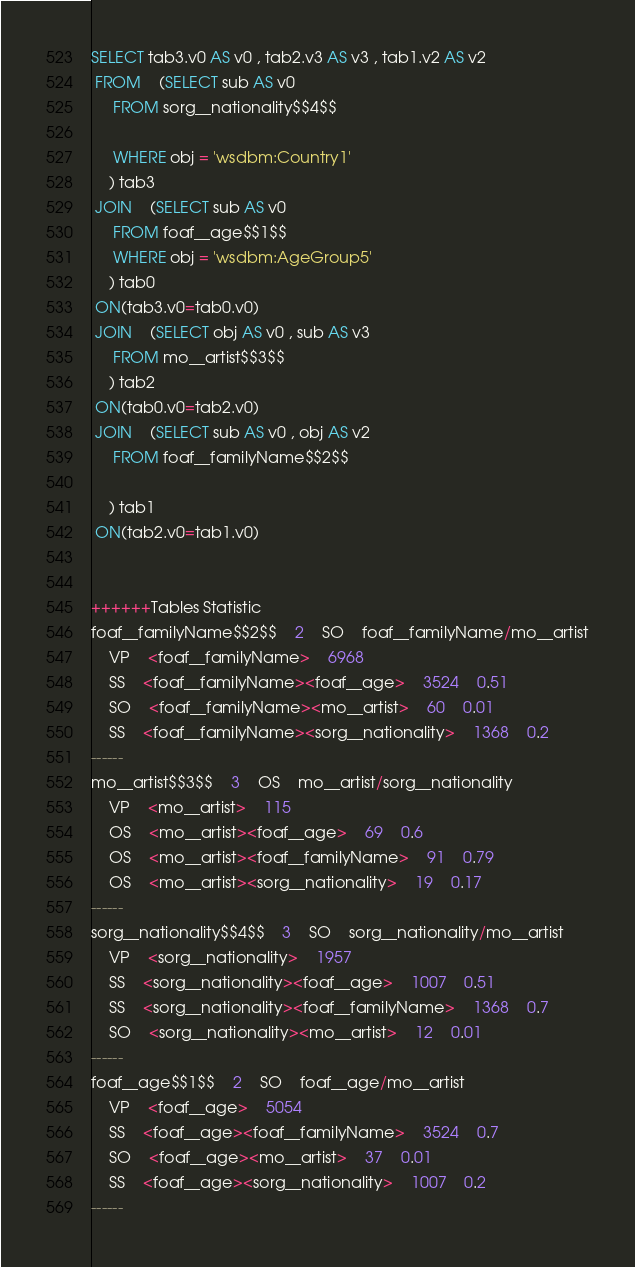<code> <loc_0><loc_0><loc_500><loc_500><_SQL_>SELECT tab3.v0 AS v0 , tab2.v3 AS v3 , tab1.v2 AS v2 
 FROM    (SELECT sub AS v0 
	 FROM sorg__nationality$$4$$
	 
	 WHERE obj = 'wsdbm:Country1'
	) tab3
 JOIN    (SELECT sub AS v0 
	 FROM foaf__age$$1$$ 
	 WHERE obj = 'wsdbm:AgeGroup5'
	) tab0
 ON(tab3.v0=tab0.v0)
 JOIN    (SELECT obj AS v0 , sub AS v3 
	 FROM mo__artist$$3$$
	) tab2
 ON(tab0.v0=tab2.v0)
 JOIN    (SELECT sub AS v0 , obj AS v2 
	 FROM foaf__familyName$$2$$
	
	) tab1
 ON(tab2.v0=tab1.v0)


++++++Tables Statistic
foaf__familyName$$2$$	2	SO	foaf__familyName/mo__artist
	VP	<foaf__familyName>	6968
	SS	<foaf__familyName><foaf__age>	3524	0.51
	SO	<foaf__familyName><mo__artist>	60	0.01
	SS	<foaf__familyName><sorg__nationality>	1368	0.2
------
mo__artist$$3$$	3	OS	mo__artist/sorg__nationality
	VP	<mo__artist>	115
	OS	<mo__artist><foaf__age>	69	0.6
	OS	<mo__artist><foaf__familyName>	91	0.79
	OS	<mo__artist><sorg__nationality>	19	0.17
------
sorg__nationality$$4$$	3	SO	sorg__nationality/mo__artist
	VP	<sorg__nationality>	1957
	SS	<sorg__nationality><foaf__age>	1007	0.51
	SS	<sorg__nationality><foaf__familyName>	1368	0.7
	SO	<sorg__nationality><mo__artist>	12	0.01
------
foaf__age$$1$$	2	SO	foaf__age/mo__artist
	VP	<foaf__age>	5054
	SS	<foaf__age><foaf__familyName>	3524	0.7
	SO	<foaf__age><mo__artist>	37	0.01
	SS	<foaf__age><sorg__nationality>	1007	0.2
------
</code> 